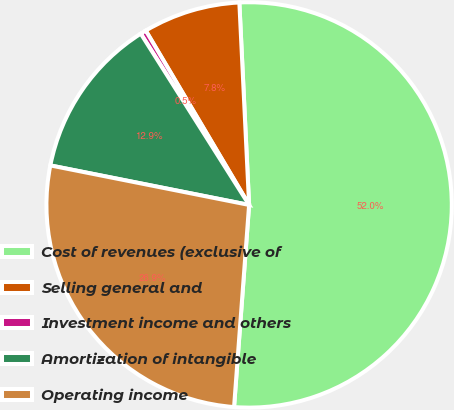Convert chart to OTSL. <chart><loc_0><loc_0><loc_500><loc_500><pie_chart><fcel>Cost of revenues (exclusive of<fcel>Selling general and<fcel>Investment income and others<fcel>Amortization of intangible<fcel>Operating income<nl><fcel>51.95%<fcel>7.75%<fcel>0.46%<fcel>12.9%<fcel>26.94%<nl></chart> 